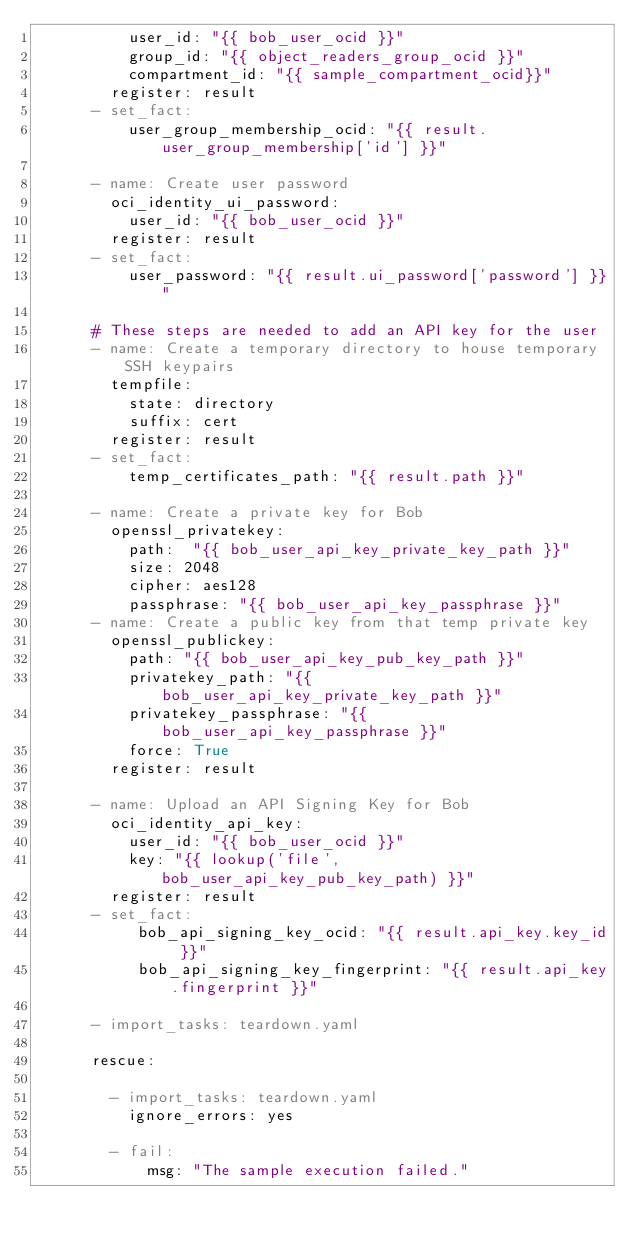Convert code to text. <code><loc_0><loc_0><loc_500><loc_500><_YAML_>          user_id: "{{ bob_user_ocid }}"
          group_id: "{{ object_readers_group_ocid }}"
          compartment_id: "{{ sample_compartment_ocid}}"
        register: result
      - set_fact:
          user_group_membership_ocid: "{{ result.user_group_membership['id'] }}"

      - name: Create user password
        oci_identity_ui_password:
          user_id: "{{ bob_user_ocid }}"
        register: result
      - set_fact:
          user_password: "{{ result.ui_password['password'] }}"

      # These steps are needed to add an API key for the user
      - name: Create a temporary directory to house temporary SSH keypairs
        tempfile:
          state: directory
          suffix: cert
        register: result
      - set_fact:
          temp_certificates_path: "{{ result.path }}"

      - name: Create a private key for Bob
        openssl_privatekey:
          path:  "{{ bob_user_api_key_private_key_path }}"
          size: 2048
          cipher: aes128
          passphrase: "{{ bob_user_api_key_passphrase }}"
      - name: Create a public key from that temp private key
        openssl_publickey:
          path: "{{ bob_user_api_key_pub_key_path }}"
          privatekey_path: "{{ bob_user_api_key_private_key_path }}"
          privatekey_passphrase: "{{ bob_user_api_key_passphrase }}"
          force: True
        register: result

      - name: Upload an API Signing Key for Bob
        oci_identity_api_key:
          user_id: "{{ bob_user_ocid }}"
          key: "{{ lookup('file', bob_user_api_key_pub_key_path) }}"
        register: result
      - set_fact:
           bob_api_signing_key_ocid: "{{ result.api_key.key_id }}"
           bob_api_signing_key_fingerprint: "{{ result.api_key.fingerprint }}"

      - import_tasks: teardown.yaml

      rescue:

        - import_tasks: teardown.yaml
          ignore_errors: yes

        - fail:
            msg: "The sample execution failed."</code> 